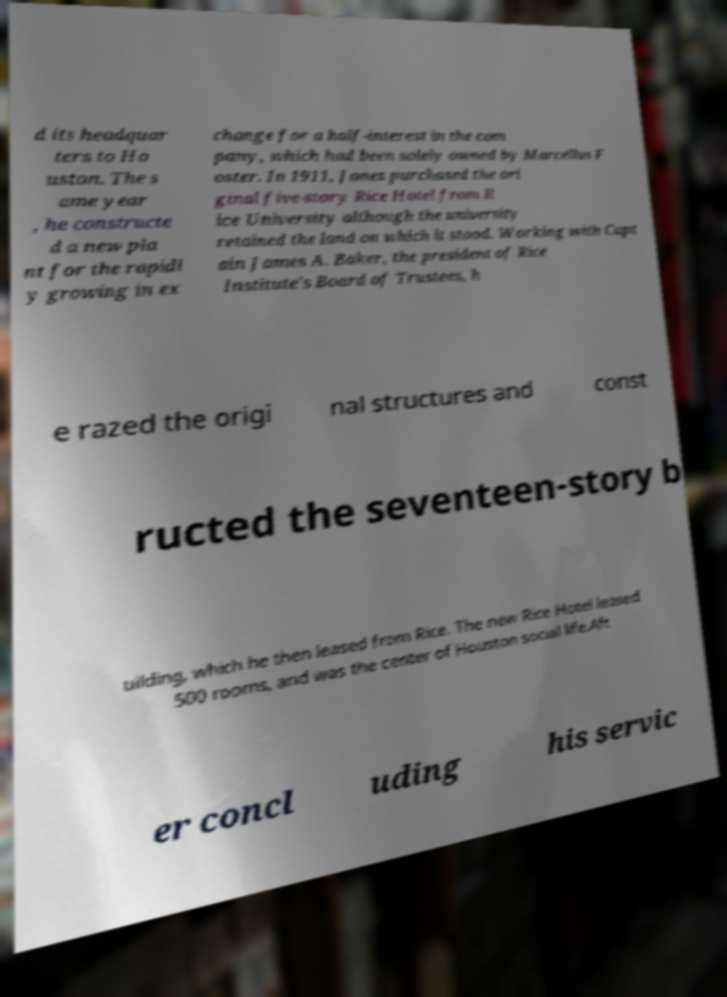There's text embedded in this image that I need extracted. Can you transcribe it verbatim? d its headquar ters to Ho uston. The s ame year , he constructe d a new pla nt for the rapidl y growing in ex change for a half-interest in the com pany, which had been solely owned by Marcellus F oster. In 1911, Jones purchased the ori ginal five-story Rice Hotel from R ice University although the university retained the land on which it stood. Working with Capt ain James A. Baker, the president of Rice Institute's Board of Trustees, h e razed the origi nal structures and const ructed the seventeen-story b uilding, which he then leased from Rice. The new Rice Hotel leased 500 rooms, and was the center of Houston social life.Aft er concl uding his servic 